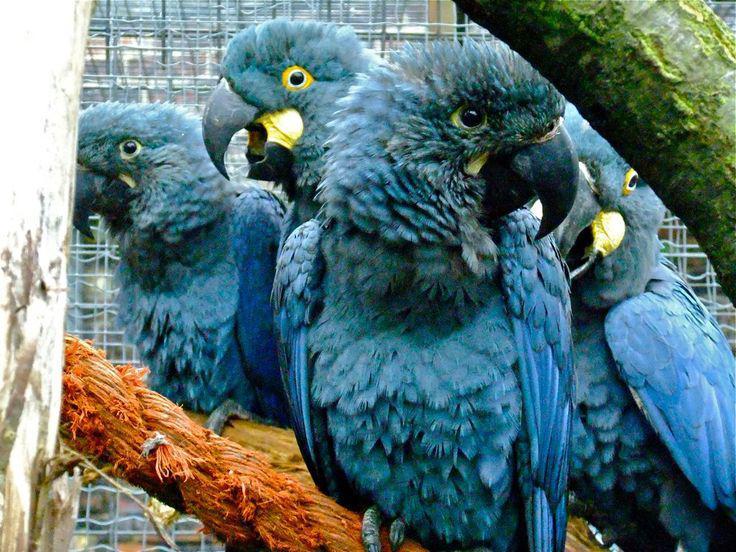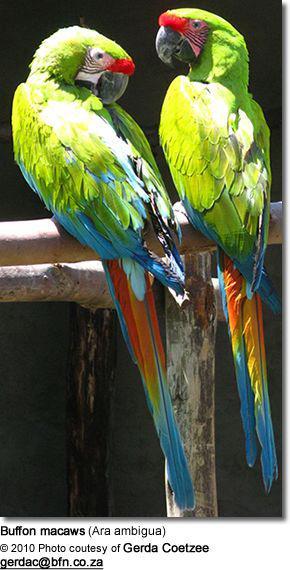The first image is the image on the left, the second image is the image on the right. Examine the images to the left and right. Is the description "An image shows a single parrot in flight." accurate? Answer yes or no. No. 